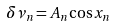Convert formula to latex. <formula><loc_0><loc_0><loc_500><loc_500>\delta \nu _ { n } = A _ { n } \cos x _ { n }</formula> 